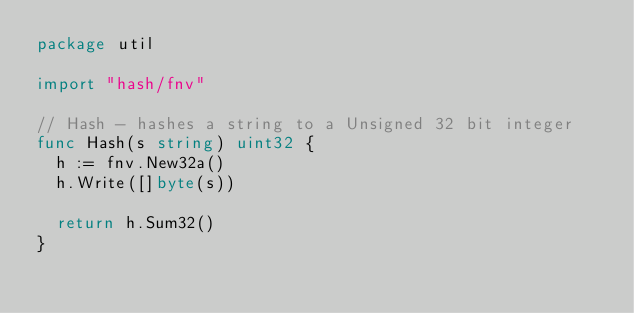<code> <loc_0><loc_0><loc_500><loc_500><_Go_>package util

import "hash/fnv"

// Hash - hashes a string to a Unsigned 32 bit integer
func Hash(s string) uint32 {
	h := fnv.New32a()
	h.Write([]byte(s))

	return h.Sum32()
}
</code> 